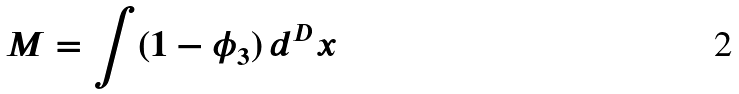Convert formula to latex. <formula><loc_0><loc_0><loc_500><loc_500>M = \int ( 1 - \phi _ { 3 } ) \, d ^ { D } x</formula> 